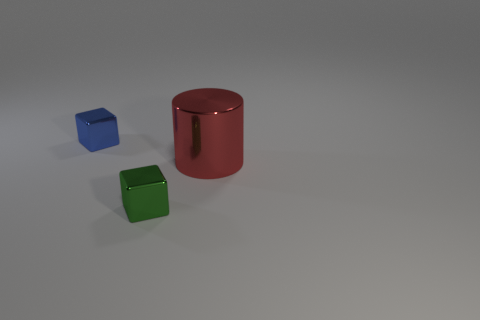Add 3 small cyan shiny cylinders. How many objects exist? 6 Subtract all cubes. How many objects are left? 1 Subtract 1 blue blocks. How many objects are left? 2 Subtract all large metal things. Subtract all small gray blocks. How many objects are left? 2 Add 1 large red cylinders. How many large red cylinders are left? 2 Add 1 small metal cubes. How many small metal cubes exist? 3 